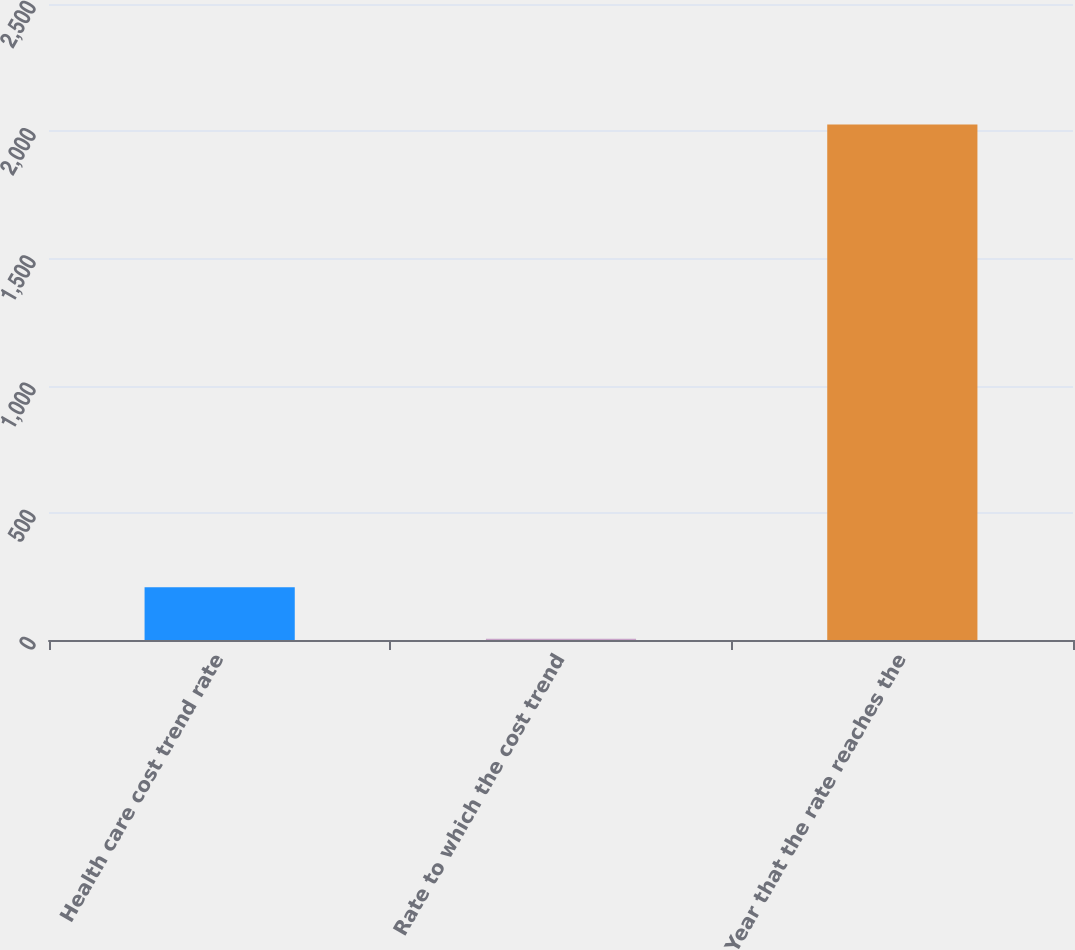Convert chart. <chart><loc_0><loc_0><loc_500><loc_500><bar_chart><fcel>Health care cost trend rate<fcel>Rate to which the cost trend<fcel>Year that the rate reaches the<nl><fcel>207.1<fcel>5<fcel>2026<nl></chart> 